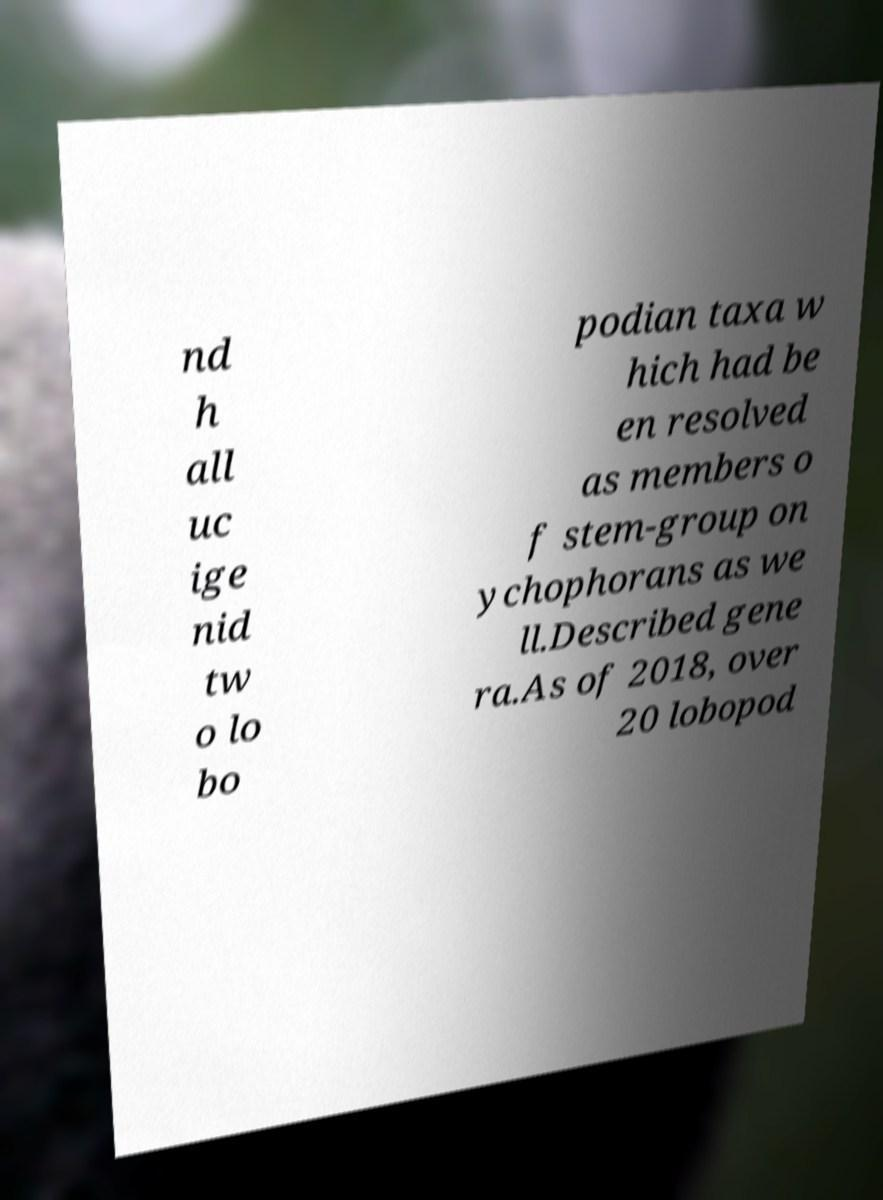Can you read and provide the text displayed in the image?This photo seems to have some interesting text. Can you extract and type it out for me? nd h all uc ige nid tw o lo bo podian taxa w hich had be en resolved as members o f stem-group on ychophorans as we ll.Described gene ra.As of 2018, over 20 lobopod 